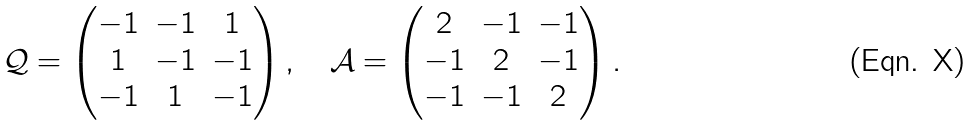Convert formula to latex. <formula><loc_0><loc_0><loc_500><loc_500>\mathcal { Q } = \begin{pmatrix} - 1 & - 1 & 1 \\ 1 & - 1 & - 1 \\ - 1 & 1 & - 1 \end{pmatrix} , \quad \mathcal { A } = \begin{pmatrix} 2 & - 1 & - 1 \\ - 1 & 2 & - 1 \\ - 1 & - 1 & 2 \end{pmatrix} .</formula> 